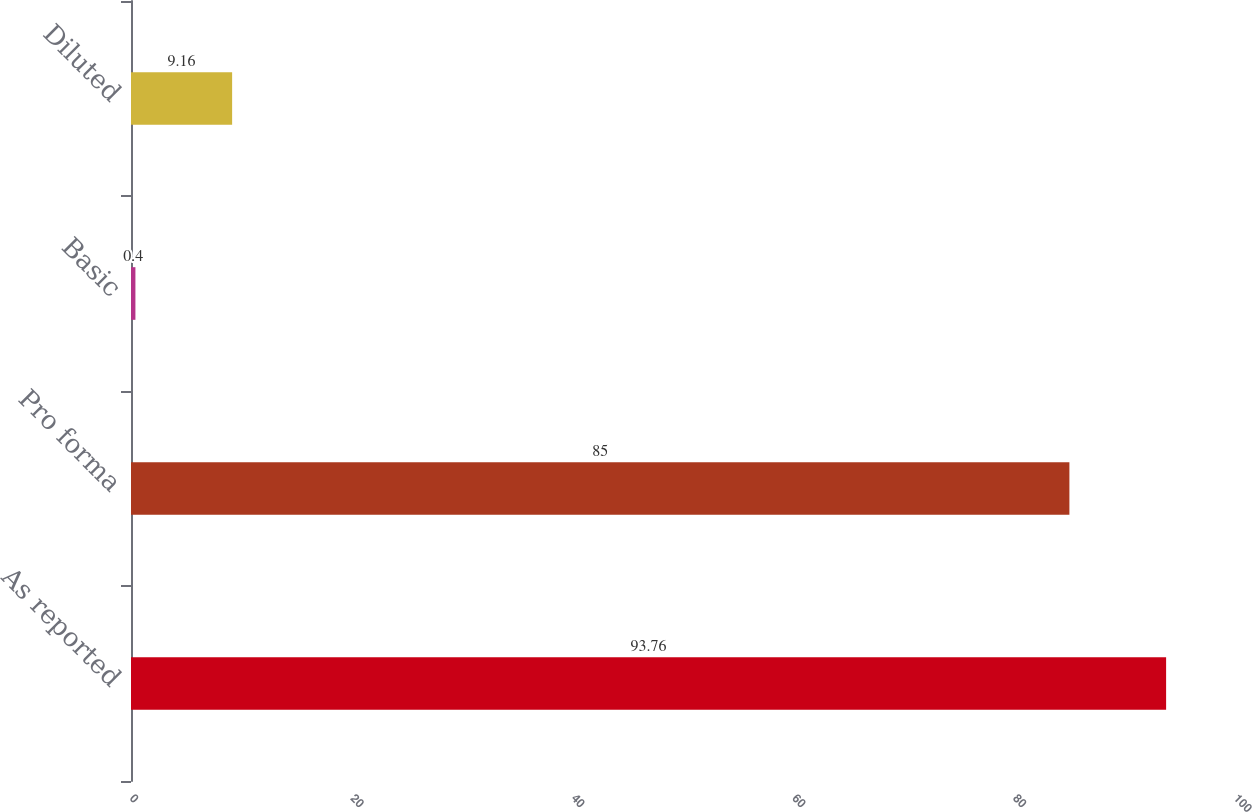Convert chart to OTSL. <chart><loc_0><loc_0><loc_500><loc_500><bar_chart><fcel>As reported<fcel>Pro forma<fcel>Basic<fcel>Diluted<nl><fcel>93.76<fcel>85<fcel>0.4<fcel>9.16<nl></chart> 